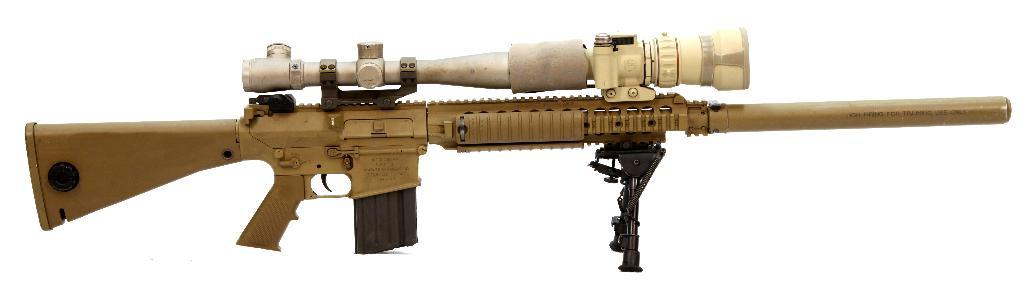What is the main object in the foreground of the image? There is a gun in the foreground of the image. What color is the background of the image? The background of the image is white. What type of plate is placed on the sofa in the image? There is no plate or sofa present in the image; it only features a gun in the foreground and a white background. 